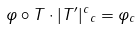<formula> <loc_0><loc_0><loc_500><loc_500>\| \varphi \circ T \cdot | T ^ { \prime } | ^ { c } \| _ { c } = \| \varphi \| _ { c }</formula> 